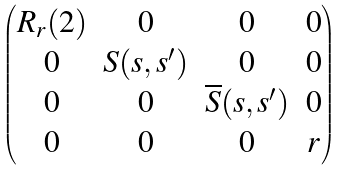<formula> <loc_0><loc_0><loc_500><loc_500>\begin{pmatrix} R _ { r } ( 2 ) & 0 & 0 & 0 \\ 0 & S ( s , s ^ { \prime } ) & 0 & 0 \\ 0 & 0 & \overline { S } ( s , s ^ { \prime } ) & 0 \\ 0 & 0 & 0 & r \end{pmatrix}</formula> 